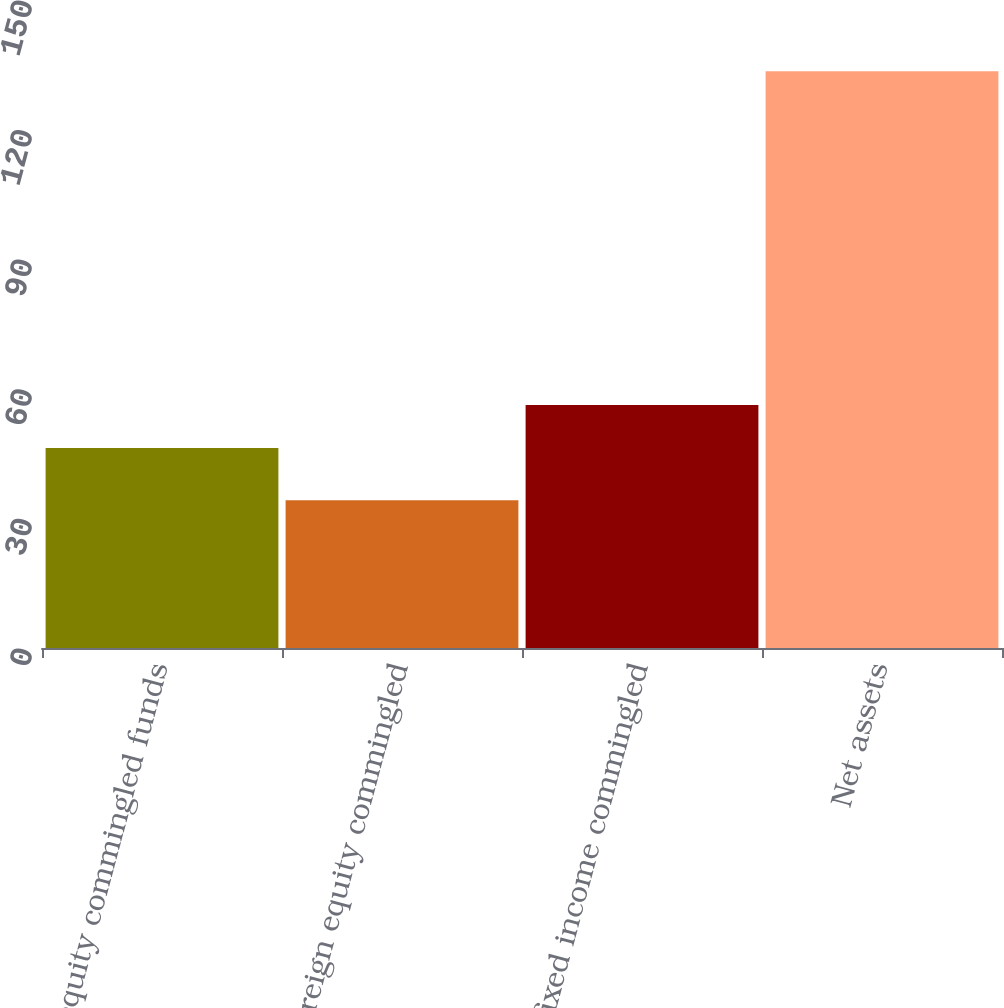<chart> <loc_0><loc_0><loc_500><loc_500><bar_chart><fcel>UK equity commingled funds<fcel>Foreign equity commingled<fcel>UK fixed income commingled<fcel>Net assets<nl><fcel>46.3<fcel>34.2<fcel>56.23<fcel>133.5<nl></chart> 